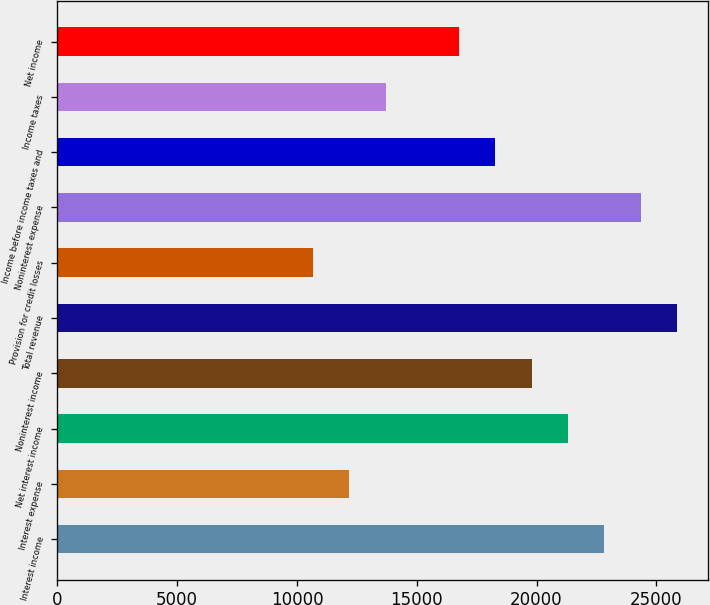Convert chart to OTSL. <chart><loc_0><loc_0><loc_500><loc_500><bar_chart><fcel>Interest income<fcel>Interest expense<fcel>Net interest income<fcel>Noninterest income<fcel>Total revenue<fcel>Provision for credit losses<fcel>Noninterest expense<fcel>Income before income taxes and<fcel>Income taxes<fcel>Net income<nl><fcel>22836.5<fcel>12180.4<fcel>21314.2<fcel>19791.9<fcel>25881.1<fcel>10658.1<fcel>24358.8<fcel>18269.6<fcel>13702.7<fcel>16747.3<nl></chart> 